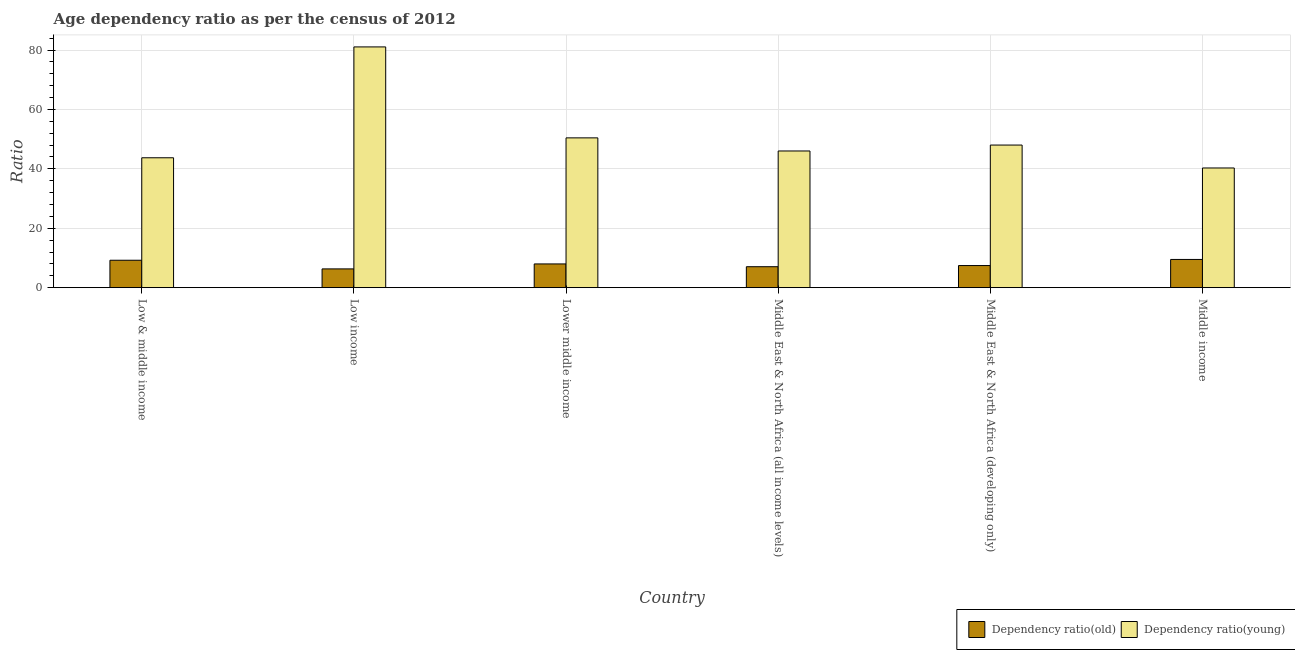How many different coloured bars are there?
Make the answer very short. 2. How many groups of bars are there?
Your answer should be compact. 6. Are the number of bars per tick equal to the number of legend labels?
Keep it short and to the point. Yes. Are the number of bars on each tick of the X-axis equal?
Your answer should be compact. Yes. How many bars are there on the 6th tick from the left?
Make the answer very short. 2. How many bars are there on the 1st tick from the right?
Offer a very short reply. 2. What is the label of the 2nd group of bars from the left?
Offer a very short reply. Low income. What is the age dependency ratio(young) in Middle East & North Africa (developing only)?
Ensure brevity in your answer.  48.02. Across all countries, what is the maximum age dependency ratio(old)?
Make the answer very short. 9.5. Across all countries, what is the minimum age dependency ratio(young)?
Ensure brevity in your answer.  40.3. In which country was the age dependency ratio(young) maximum?
Your response must be concise. Low income. What is the total age dependency ratio(young) in the graph?
Offer a very short reply. 309.56. What is the difference between the age dependency ratio(old) in Low & middle income and that in Lower middle income?
Ensure brevity in your answer.  1.24. What is the difference between the age dependency ratio(young) in Middle income and the age dependency ratio(old) in Low & middle income?
Offer a terse response. 31.07. What is the average age dependency ratio(old) per country?
Your answer should be very brief. 7.92. What is the difference between the age dependency ratio(young) and age dependency ratio(old) in Low & middle income?
Offer a terse response. 34.5. What is the ratio of the age dependency ratio(young) in Low & middle income to that in Lower middle income?
Provide a short and direct response. 0.87. Is the difference between the age dependency ratio(young) in Middle East & North Africa (all income levels) and Middle income greater than the difference between the age dependency ratio(old) in Middle East & North Africa (all income levels) and Middle income?
Provide a short and direct response. Yes. What is the difference between the highest and the second highest age dependency ratio(old)?
Offer a terse response. 0.27. What is the difference between the highest and the lowest age dependency ratio(young)?
Keep it short and to the point. 40.76. Is the sum of the age dependency ratio(old) in Low & middle income and Low income greater than the maximum age dependency ratio(young) across all countries?
Make the answer very short. No. What does the 2nd bar from the left in Low & middle income represents?
Make the answer very short. Dependency ratio(young). What does the 1st bar from the right in Middle East & North Africa (developing only) represents?
Make the answer very short. Dependency ratio(young). Are all the bars in the graph horizontal?
Your answer should be compact. No. What is the difference between two consecutive major ticks on the Y-axis?
Provide a succinct answer. 20. Does the graph contain grids?
Your answer should be very brief. Yes. Where does the legend appear in the graph?
Your answer should be compact. Bottom right. How many legend labels are there?
Keep it short and to the point. 2. What is the title of the graph?
Your answer should be very brief. Age dependency ratio as per the census of 2012. Does "Malaria" appear as one of the legend labels in the graph?
Ensure brevity in your answer.  No. What is the label or title of the X-axis?
Offer a very short reply. Country. What is the label or title of the Y-axis?
Ensure brevity in your answer.  Ratio. What is the Ratio in Dependency ratio(old) in Low & middle income?
Provide a succinct answer. 9.23. What is the Ratio in Dependency ratio(young) in Low & middle income?
Your answer should be very brief. 43.74. What is the Ratio of Dependency ratio(old) in Low income?
Keep it short and to the point. 6.32. What is the Ratio in Dependency ratio(young) in Low income?
Your answer should be compact. 81.06. What is the Ratio in Dependency ratio(old) in Lower middle income?
Your answer should be very brief. 7.99. What is the Ratio of Dependency ratio(young) in Lower middle income?
Ensure brevity in your answer.  50.43. What is the Ratio of Dependency ratio(old) in Middle East & North Africa (all income levels)?
Your answer should be compact. 7.06. What is the Ratio of Dependency ratio(young) in Middle East & North Africa (all income levels)?
Offer a terse response. 46.02. What is the Ratio in Dependency ratio(old) in Middle East & North Africa (developing only)?
Give a very brief answer. 7.45. What is the Ratio in Dependency ratio(young) in Middle East & North Africa (developing only)?
Provide a succinct answer. 48.02. What is the Ratio of Dependency ratio(old) in Middle income?
Provide a short and direct response. 9.5. What is the Ratio of Dependency ratio(young) in Middle income?
Offer a terse response. 40.3. Across all countries, what is the maximum Ratio in Dependency ratio(old)?
Offer a very short reply. 9.5. Across all countries, what is the maximum Ratio in Dependency ratio(young)?
Offer a very short reply. 81.06. Across all countries, what is the minimum Ratio of Dependency ratio(old)?
Offer a terse response. 6.32. Across all countries, what is the minimum Ratio of Dependency ratio(young)?
Provide a short and direct response. 40.3. What is the total Ratio of Dependency ratio(old) in the graph?
Ensure brevity in your answer.  47.54. What is the total Ratio of Dependency ratio(young) in the graph?
Provide a succinct answer. 309.56. What is the difference between the Ratio in Dependency ratio(old) in Low & middle income and that in Low income?
Offer a very short reply. 2.91. What is the difference between the Ratio of Dependency ratio(young) in Low & middle income and that in Low income?
Your answer should be very brief. -37.32. What is the difference between the Ratio in Dependency ratio(old) in Low & middle income and that in Lower middle income?
Keep it short and to the point. 1.24. What is the difference between the Ratio in Dependency ratio(young) in Low & middle income and that in Lower middle income?
Offer a terse response. -6.7. What is the difference between the Ratio of Dependency ratio(old) in Low & middle income and that in Middle East & North Africa (all income levels)?
Provide a succinct answer. 2.18. What is the difference between the Ratio in Dependency ratio(young) in Low & middle income and that in Middle East & North Africa (all income levels)?
Give a very brief answer. -2.29. What is the difference between the Ratio in Dependency ratio(old) in Low & middle income and that in Middle East & North Africa (developing only)?
Ensure brevity in your answer.  1.79. What is the difference between the Ratio of Dependency ratio(young) in Low & middle income and that in Middle East & North Africa (developing only)?
Ensure brevity in your answer.  -4.28. What is the difference between the Ratio of Dependency ratio(old) in Low & middle income and that in Middle income?
Ensure brevity in your answer.  -0.27. What is the difference between the Ratio of Dependency ratio(young) in Low & middle income and that in Middle income?
Ensure brevity in your answer.  3.44. What is the difference between the Ratio of Dependency ratio(old) in Low income and that in Lower middle income?
Give a very brief answer. -1.67. What is the difference between the Ratio in Dependency ratio(young) in Low income and that in Lower middle income?
Your response must be concise. 30.63. What is the difference between the Ratio in Dependency ratio(old) in Low income and that in Middle East & North Africa (all income levels)?
Offer a very short reply. -0.74. What is the difference between the Ratio of Dependency ratio(young) in Low income and that in Middle East & North Africa (all income levels)?
Your answer should be very brief. 35.04. What is the difference between the Ratio in Dependency ratio(old) in Low income and that in Middle East & North Africa (developing only)?
Your response must be concise. -1.13. What is the difference between the Ratio in Dependency ratio(young) in Low income and that in Middle East & North Africa (developing only)?
Offer a terse response. 33.04. What is the difference between the Ratio in Dependency ratio(old) in Low income and that in Middle income?
Ensure brevity in your answer.  -3.18. What is the difference between the Ratio in Dependency ratio(young) in Low income and that in Middle income?
Offer a very short reply. 40.76. What is the difference between the Ratio of Dependency ratio(old) in Lower middle income and that in Middle East & North Africa (all income levels)?
Provide a succinct answer. 0.93. What is the difference between the Ratio of Dependency ratio(young) in Lower middle income and that in Middle East & North Africa (all income levels)?
Provide a succinct answer. 4.41. What is the difference between the Ratio of Dependency ratio(old) in Lower middle income and that in Middle East & North Africa (developing only)?
Offer a very short reply. 0.54. What is the difference between the Ratio in Dependency ratio(young) in Lower middle income and that in Middle East & North Africa (developing only)?
Your answer should be very brief. 2.42. What is the difference between the Ratio of Dependency ratio(old) in Lower middle income and that in Middle income?
Offer a very short reply. -1.51. What is the difference between the Ratio of Dependency ratio(young) in Lower middle income and that in Middle income?
Your answer should be very brief. 10.14. What is the difference between the Ratio in Dependency ratio(old) in Middle East & North Africa (all income levels) and that in Middle East & North Africa (developing only)?
Keep it short and to the point. -0.39. What is the difference between the Ratio in Dependency ratio(young) in Middle East & North Africa (all income levels) and that in Middle East & North Africa (developing only)?
Provide a succinct answer. -1.99. What is the difference between the Ratio in Dependency ratio(old) in Middle East & North Africa (all income levels) and that in Middle income?
Your response must be concise. -2.44. What is the difference between the Ratio in Dependency ratio(young) in Middle East & North Africa (all income levels) and that in Middle income?
Your answer should be compact. 5.72. What is the difference between the Ratio in Dependency ratio(old) in Middle East & North Africa (developing only) and that in Middle income?
Offer a terse response. -2.05. What is the difference between the Ratio of Dependency ratio(young) in Middle East & North Africa (developing only) and that in Middle income?
Provide a succinct answer. 7.72. What is the difference between the Ratio in Dependency ratio(old) in Low & middle income and the Ratio in Dependency ratio(young) in Low income?
Offer a terse response. -71.83. What is the difference between the Ratio of Dependency ratio(old) in Low & middle income and the Ratio of Dependency ratio(young) in Lower middle income?
Keep it short and to the point. -41.2. What is the difference between the Ratio of Dependency ratio(old) in Low & middle income and the Ratio of Dependency ratio(young) in Middle East & North Africa (all income levels)?
Offer a terse response. -36.79. What is the difference between the Ratio in Dependency ratio(old) in Low & middle income and the Ratio in Dependency ratio(young) in Middle East & North Africa (developing only)?
Your response must be concise. -38.78. What is the difference between the Ratio of Dependency ratio(old) in Low & middle income and the Ratio of Dependency ratio(young) in Middle income?
Keep it short and to the point. -31.07. What is the difference between the Ratio of Dependency ratio(old) in Low income and the Ratio of Dependency ratio(young) in Lower middle income?
Your response must be concise. -44.11. What is the difference between the Ratio in Dependency ratio(old) in Low income and the Ratio in Dependency ratio(young) in Middle East & North Africa (all income levels)?
Provide a succinct answer. -39.7. What is the difference between the Ratio of Dependency ratio(old) in Low income and the Ratio of Dependency ratio(young) in Middle East & North Africa (developing only)?
Offer a terse response. -41.7. What is the difference between the Ratio in Dependency ratio(old) in Low income and the Ratio in Dependency ratio(young) in Middle income?
Give a very brief answer. -33.98. What is the difference between the Ratio of Dependency ratio(old) in Lower middle income and the Ratio of Dependency ratio(young) in Middle East & North Africa (all income levels)?
Provide a short and direct response. -38.03. What is the difference between the Ratio of Dependency ratio(old) in Lower middle income and the Ratio of Dependency ratio(young) in Middle East & North Africa (developing only)?
Offer a terse response. -40.02. What is the difference between the Ratio in Dependency ratio(old) in Lower middle income and the Ratio in Dependency ratio(young) in Middle income?
Give a very brief answer. -32.31. What is the difference between the Ratio in Dependency ratio(old) in Middle East & North Africa (all income levels) and the Ratio in Dependency ratio(young) in Middle East & North Africa (developing only)?
Ensure brevity in your answer.  -40.96. What is the difference between the Ratio in Dependency ratio(old) in Middle East & North Africa (all income levels) and the Ratio in Dependency ratio(young) in Middle income?
Give a very brief answer. -33.24. What is the difference between the Ratio of Dependency ratio(old) in Middle East & North Africa (developing only) and the Ratio of Dependency ratio(young) in Middle income?
Offer a very short reply. -32.85. What is the average Ratio in Dependency ratio(old) per country?
Ensure brevity in your answer.  7.92. What is the average Ratio in Dependency ratio(young) per country?
Provide a succinct answer. 51.59. What is the difference between the Ratio of Dependency ratio(old) and Ratio of Dependency ratio(young) in Low & middle income?
Offer a terse response. -34.5. What is the difference between the Ratio of Dependency ratio(old) and Ratio of Dependency ratio(young) in Low income?
Keep it short and to the point. -74.74. What is the difference between the Ratio of Dependency ratio(old) and Ratio of Dependency ratio(young) in Lower middle income?
Provide a succinct answer. -42.44. What is the difference between the Ratio in Dependency ratio(old) and Ratio in Dependency ratio(young) in Middle East & North Africa (all income levels)?
Your response must be concise. -38.97. What is the difference between the Ratio in Dependency ratio(old) and Ratio in Dependency ratio(young) in Middle East & North Africa (developing only)?
Keep it short and to the point. -40.57. What is the difference between the Ratio of Dependency ratio(old) and Ratio of Dependency ratio(young) in Middle income?
Your answer should be very brief. -30.8. What is the ratio of the Ratio of Dependency ratio(old) in Low & middle income to that in Low income?
Provide a short and direct response. 1.46. What is the ratio of the Ratio of Dependency ratio(young) in Low & middle income to that in Low income?
Provide a succinct answer. 0.54. What is the ratio of the Ratio of Dependency ratio(old) in Low & middle income to that in Lower middle income?
Your answer should be very brief. 1.16. What is the ratio of the Ratio in Dependency ratio(young) in Low & middle income to that in Lower middle income?
Provide a succinct answer. 0.87. What is the ratio of the Ratio of Dependency ratio(old) in Low & middle income to that in Middle East & North Africa (all income levels)?
Give a very brief answer. 1.31. What is the ratio of the Ratio of Dependency ratio(young) in Low & middle income to that in Middle East & North Africa (all income levels)?
Offer a very short reply. 0.95. What is the ratio of the Ratio in Dependency ratio(old) in Low & middle income to that in Middle East & North Africa (developing only)?
Make the answer very short. 1.24. What is the ratio of the Ratio of Dependency ratio(young) in Low & middle income to that in Middle East & North Africa (developing only)?
Give a very brief answer. 0.91. What is the ratio of the Ratio of Dependency ratio(old) in Low & middle income to that in Middle income?
Give a very brief answer. 0.97. What is the ratio of the Ratio of Dependency ratio(young) in Low & middle income to that in Middle income?
Provide a short and direct response. 1.09. What is the ratio of the Ratio of Dependency ratio(old) in Low income to that in Lower middle income?
Give a very brief answer. 0.79. What is the ratio of the Ratio in Dependency ratio(young) in Low income to that in Lower middle income?
Your response must be concise. 1.61. What is the ratio of the Ratio of Dependency ratio(old) in Low income to that in Middle East & North Africa (all income levels)?
Offer a terse response. 0.9. What is the ratio of the Ratio in Dependency ratio(young) in Low income to that in Middle East & North Africa (all income levels)?
Offer a very short reply. 1.76. What is the ratio of the Ratio in Dependency ratio(old) in Low income to that in Middle East & North Africa (developing only)?
Make the answer very short. 0.85. What is the ratio of the Ratio in Dependency ratio(young) in Low income to that in Middle East & North Africa (developing only)?
Keep it short and to the point. 1.69. What is the ratio of the Ratio of Dependency ratio(old) in Low income to that in Middle income?
Give a very brief answer. 0.67. What is the ratio of the Ratio in Dependency ratio(young) in Low income to that in Middle income?
Provide a short and direct response. 2.01. What is the ratio of the Ratio in Dependency ratio(old) in Lower middle income to that in Middle East & North Africa (all income levels)?
Your answer should be compact. 1.13. What is the ratio of the Ratio of Dependency ratio(young) in Lower middle income to that in Middle East & North Africa (all income levels)?
Give a very brief answer. 1.1. What is the ratio of the Ratio of Dependency ratio(old) in Lower middle income to that in Middle East & North Africa (developing only)?
Offer a terse response. 1.07. What is the ratio of the Ratio in Dependency ratio(young) in Lower middle income to that in Middle East & North Africa (developing only)?
Provide a short and direct response. 1.05. What is the ratio of the Ratio in Dependency ratio(old) in Lower middle income to that in Middle income?
Ensure brevity in your answer.  0.84. What is the ratio of the Ratio of Dependency ratio(young) in Lower middle income to that in Middle income?
Your answer should be very brief. 1.25. What is the ratio of the Ratio in Dependency ratio(old) in Middle East & North Africa (all income levels) to that in Middle East & North Africa (developing only)?
Your answer should be compact. 0.95. What is the ratio of the Ratio in Dependency ratio(young) in Middle East & North Africa (all income levels) to that in Middle East & North Africa (developing only)?
Give a very brief answer. 0.96. What is the ratio of the Ratio in Dependency ratio(old) in Middle East & North Africa (all income levels) to that in Middle income?
Make the answer very short. 0.74. What is the ratio of the Ratio in Dependency ratio(young) in Middle East & North Africa (all income levels) to that in Middle income?
Make the answer very short. 1.14. What is the ratio of the Ratio in Dependency ratio(old) in Middle East & North Africa (developing only) to that in Middle income?
Provide a succinct answer. 0.78. What is the ratio of the Ratio in Dependency ratio(young) in Middle East & North Africa (developing only) to that in Middle income?
Your answer should be very brief. 1.19. What is the difference between the highest and the second highest Ratio of Dependency ratio(old)?
Provide a short and direct response. 0.27. What is the difference between the highest and the second highest Ratio in Dependency ratio(young)?
Provide a short and direct response. 30.63. What is the difference between the highest and the lowest Ratio in Dependency ratio(old)?
Offer a very short reply. 3.18. What is the difference between the highest and the lowest Ratio in Dependency ratio(young)?
Ensure brevity in your answer.  40.76. 